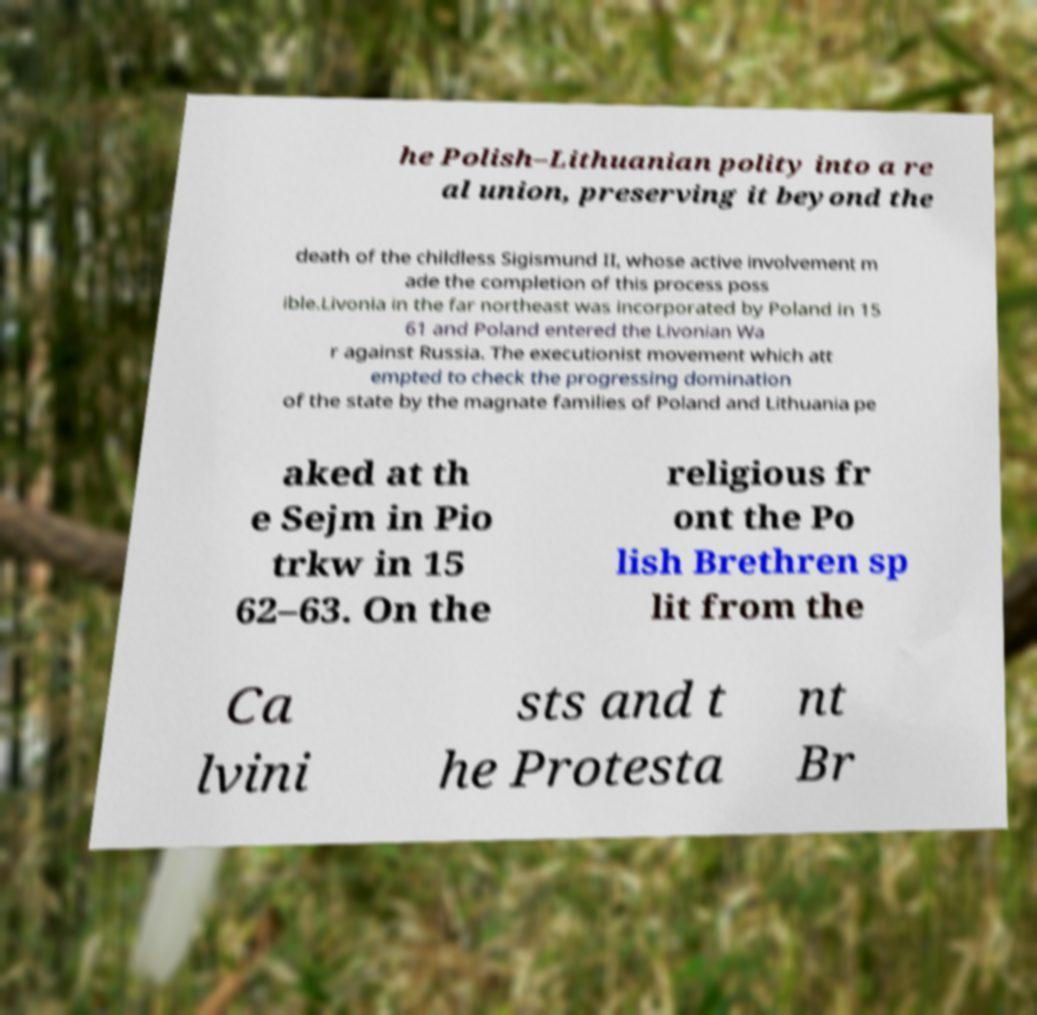Can you accurately transcribe the text from the provided image for me? he Polish–Lithuanian polity into a re al union, preserving it beyond the death of the childless Sigismund II, whose active involvement m ade the completion of this process poss ible.Livonia in the far northeast was incorporated by Poland in 15 61 and Poland entered the Livonian Wa r against Russia. The executionist movement which att empted to check the progressing domination of the state by the magnate families of Poland and Lithuania pe aked at th e Sejm in Pio trkw in 15 62–63. On the religious fr ont the Po lish Brethren sp lit from the Ca lvini sts and t he Protesta nt Br 